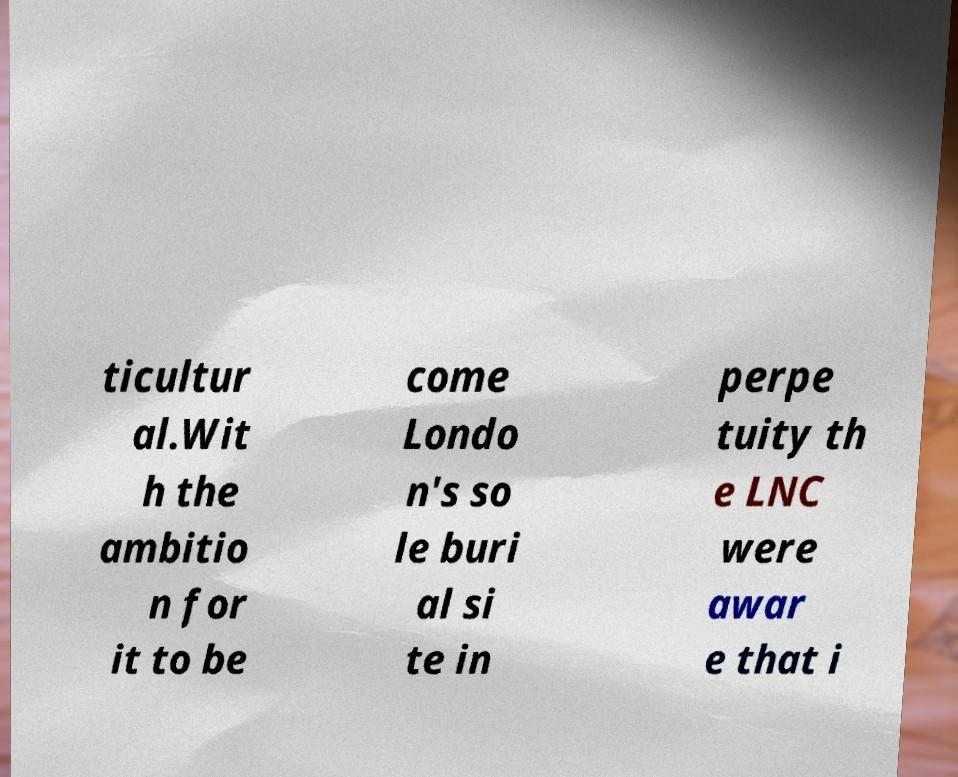What messages or text are displayed in this image? I need them in a readable, typed format. ticultur al.Wit h the ambitio n for it to be come Londo n's so le buri al si te in perpe tuity th e LNC were awar e that i 